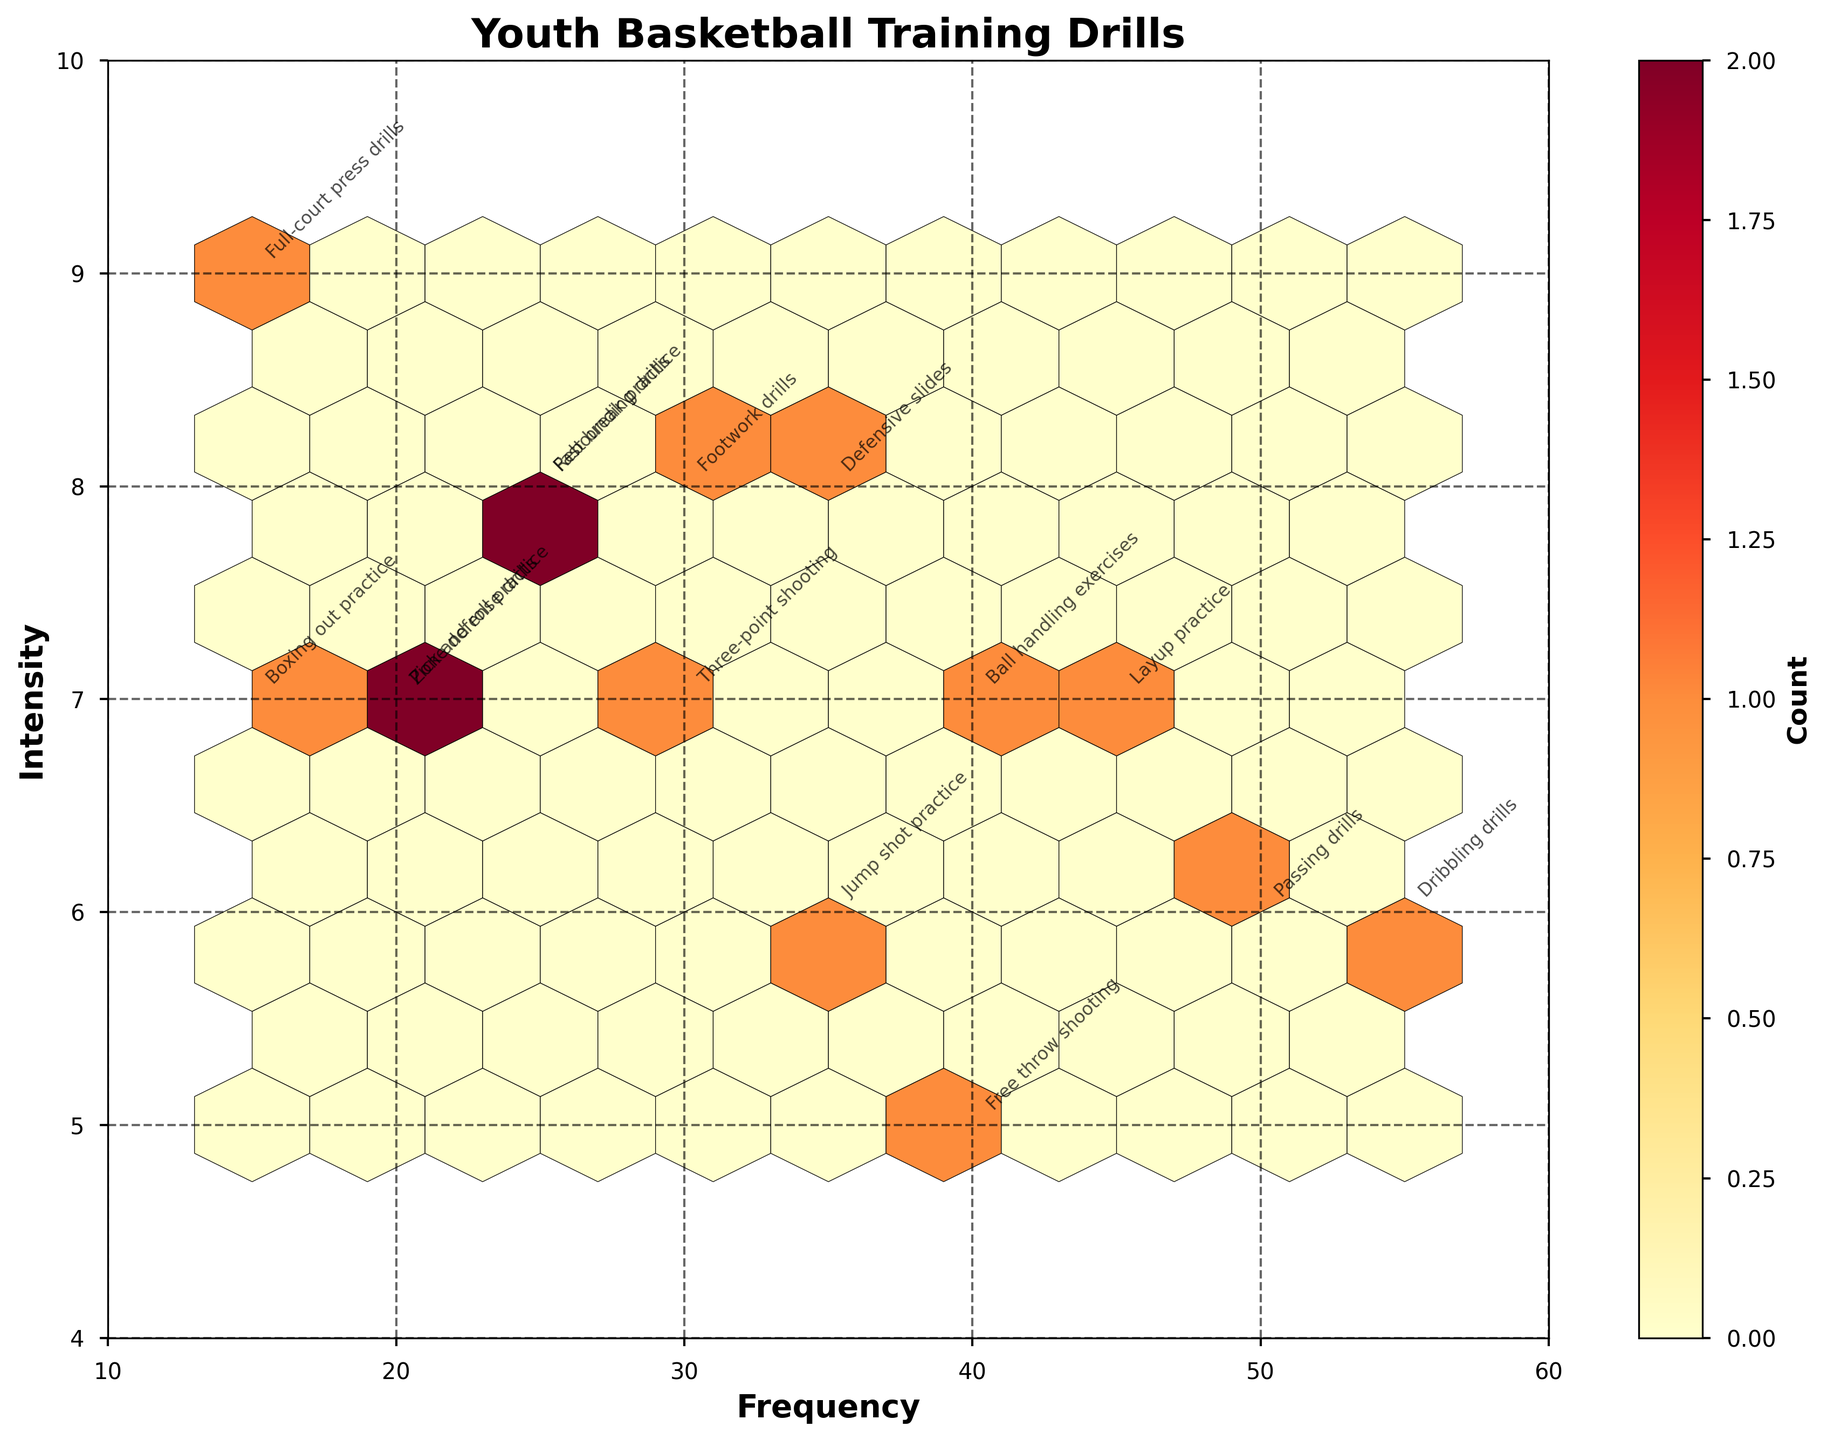What is the title of the plot? The title is displayed at the top center of the plot.
Answer: Youth Basketball Training Drills What do the x and y axes represent? The x-axis represents "Frequency" and the y-axis represents "Intensity," as labeled on the figure.
Answer: Frequency and Intensity Which drill type has the highest frequency? By locating the type of drill at the highest point along the x-axis, we see "Dribbling drills" at a frequency of 55.
Answer: Dribbling drills How many different drill types are presented? Each drill type has a text annotation, and by counting the text labels on the plot, we find there are 15 different drill types.
Answer: 15 Identify the drill type that exists at the intersection of frequency 30 and intensity 7. The annotation at the coordinates (30, 7) shows "Three-point shooting."
Answer: Three-point shooting Which drill has both high intensity and low frequency? "Full-court press drills" appears at the coordinates close to high intensity (9) and low frequency (15).
Answer: Full-court press drills What is the count of data points in the hexbin containing the highest number of points? The color intensity of the hexagonal bins indicates the count. By referring to the color bar, the bin with the highest count corresponds to the brightest color, which has the highest count labeled as 1.
Answer: 1 Compare the frequency of "Fast break practice" and "Rebounding drills". Which one is higher? The frequency of "Fast break practice" is 25, whereas "Rebounding drills" is also 25. Both drills have the same frequency.
Answer: Same frequency Where does "Defensive slides" fall on the plot in terms of intensity? The coordinates of "Defensive slides" is (35, 8), indicating high intensity.
Answer: 8 What does a more densely packed hexbin area indicate on this plot? Denser hexbin areas, as indicated by darker shades, imply that there are more drills sharing similar frequency and intensity values.
Answer: More drills clustered together 